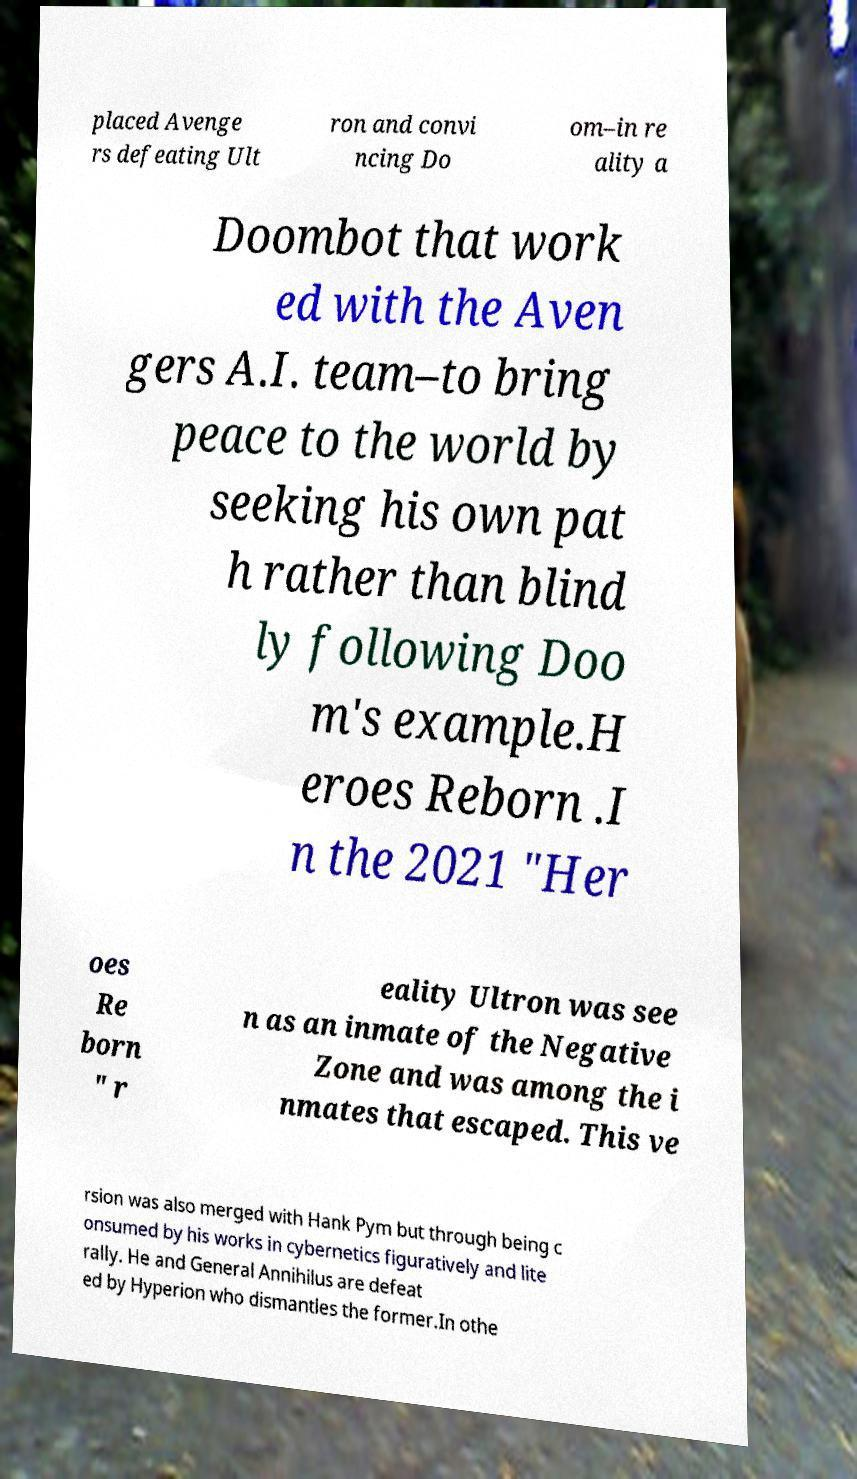Can you read and provide the text displayed in the image?This photo seems to have some interesting text. Can you extract and type it out for me? placed Avenge rs defeating Ult ron and convi ncing Do om–in re ality a Doombot that work ed with the Aven gers A.I. team–to bring peace to the world by seeking his own pat h rather than blind ly following Doo m's example.H eroes Reborn .I n the 2021 "Her oes Re born " r eality Ultron was see n as an inmate of the Negative Zone and was among the i nmates that escaped. This ve rsion was also merged with Hank Pym but through being c onsumed by his works in cybernetics figuratively and lite rally. He and General Annihilus are defeat ed by Hyperion who dismantles the former.In othe 